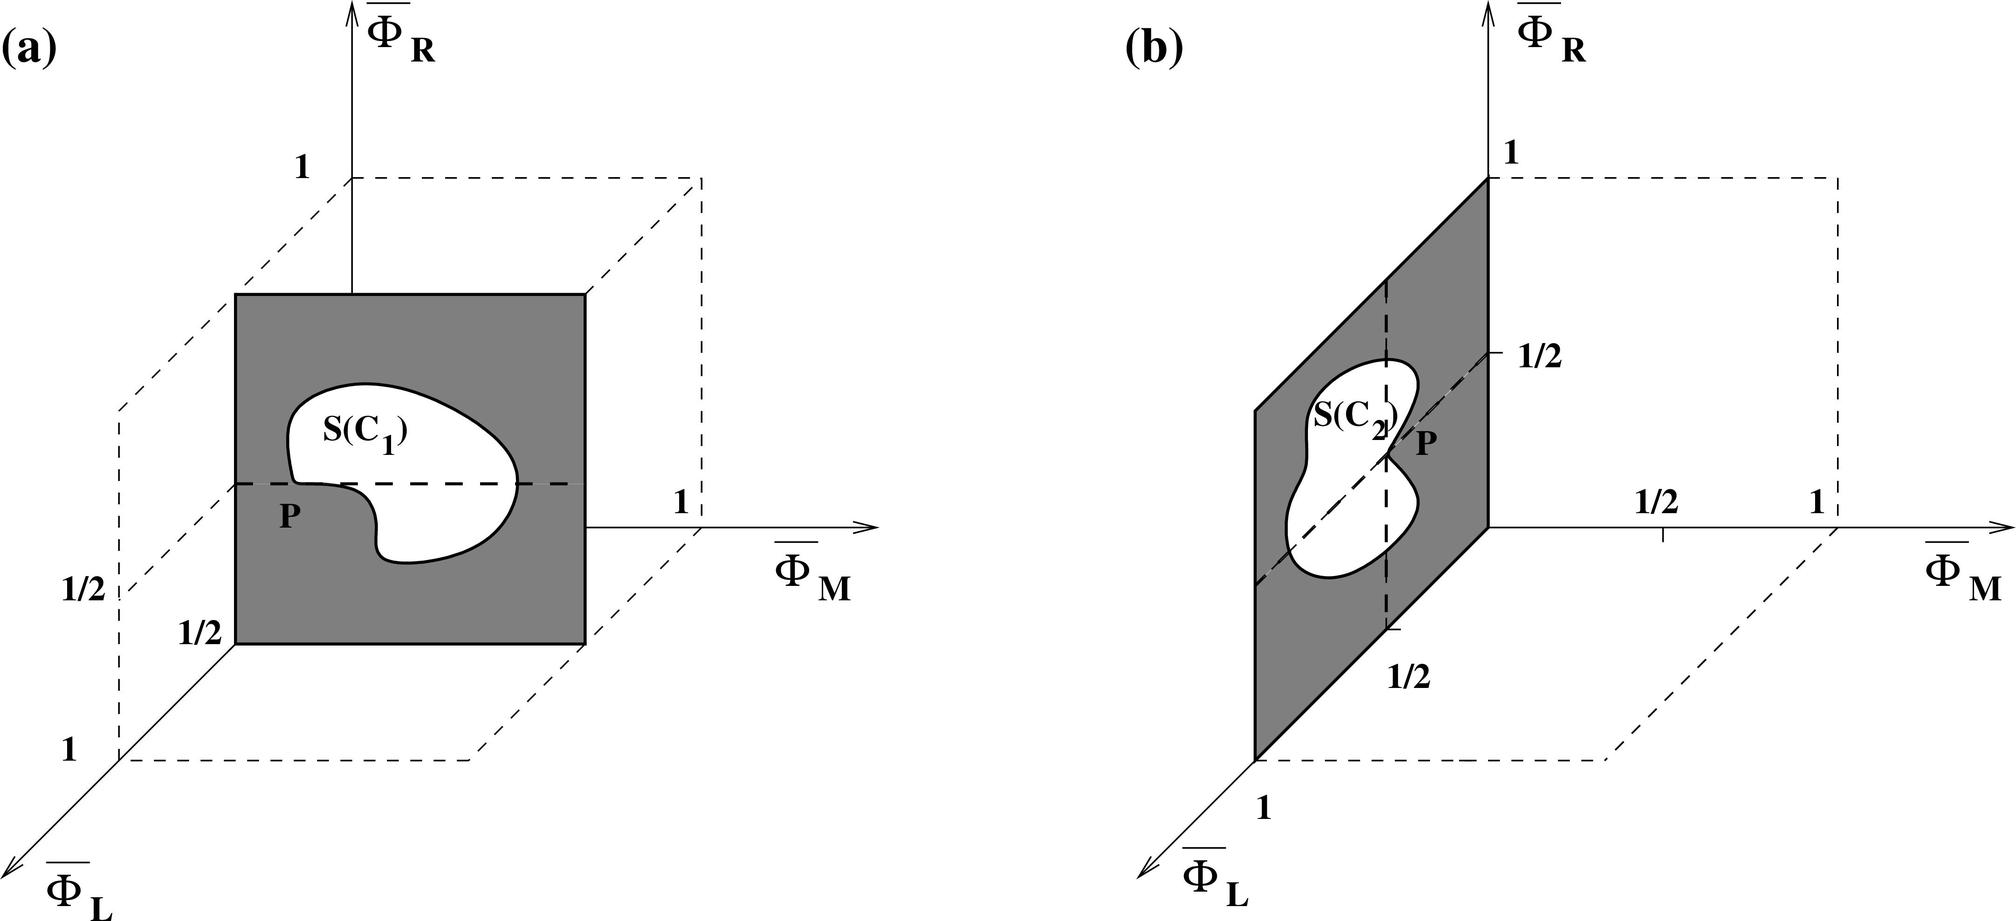In the context of the given figures, which statement accurately describes the relationship between Islam and R? A. Islam is directly proportional to R. B. Islam is inversely proportional to R. C. Islam and R are independent. D. Islam and R are the same in both figures. The diagrams you provided show the variables Islam and R plotted on perpendicular axes on a coordinate system, suggesting that they are independent of each other. Independence in this context means that the value of Islam does not influence the value of R and vice versa. This layout indicates no inherent correlation or dependency, typically implying that changes in one do not affect the other. Thus, the correct answer is C: Islam and R are independent. 